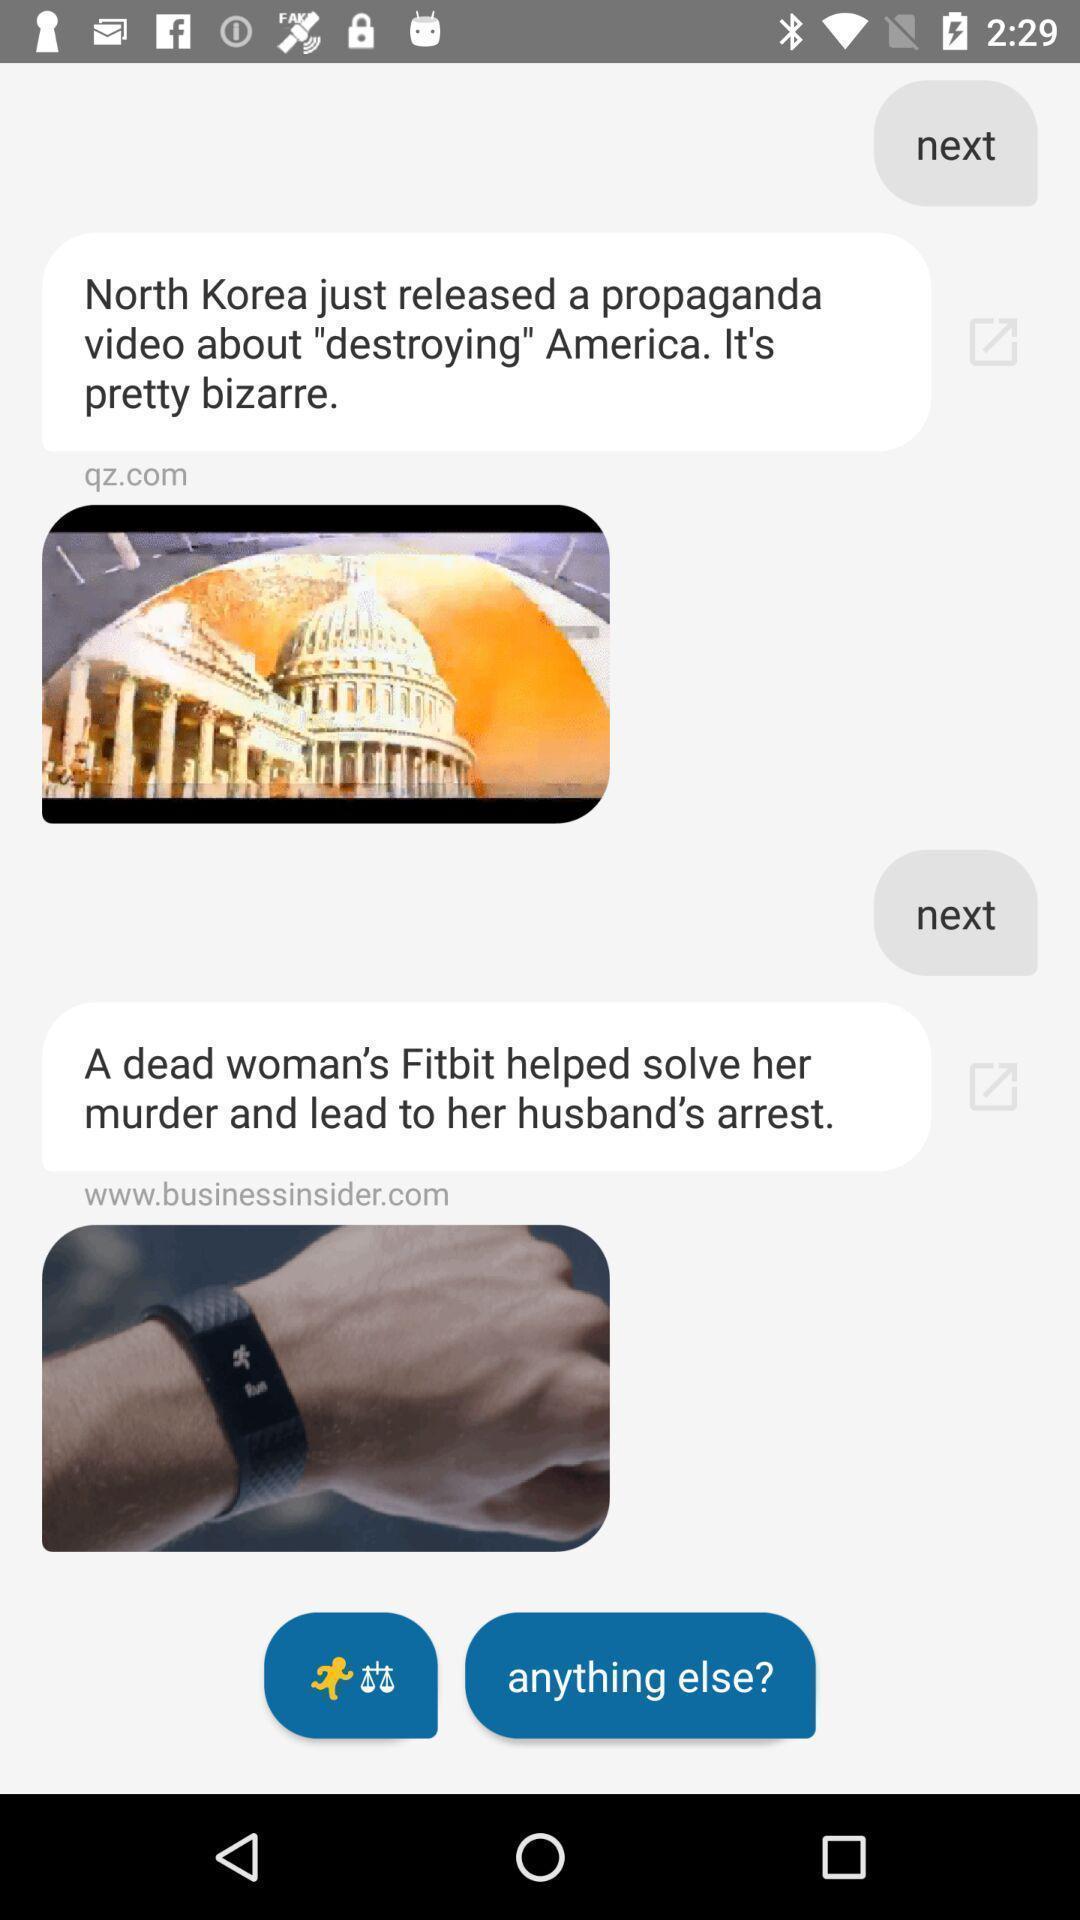Tell me about the visual elements in this screen capture. Screen showing page. 